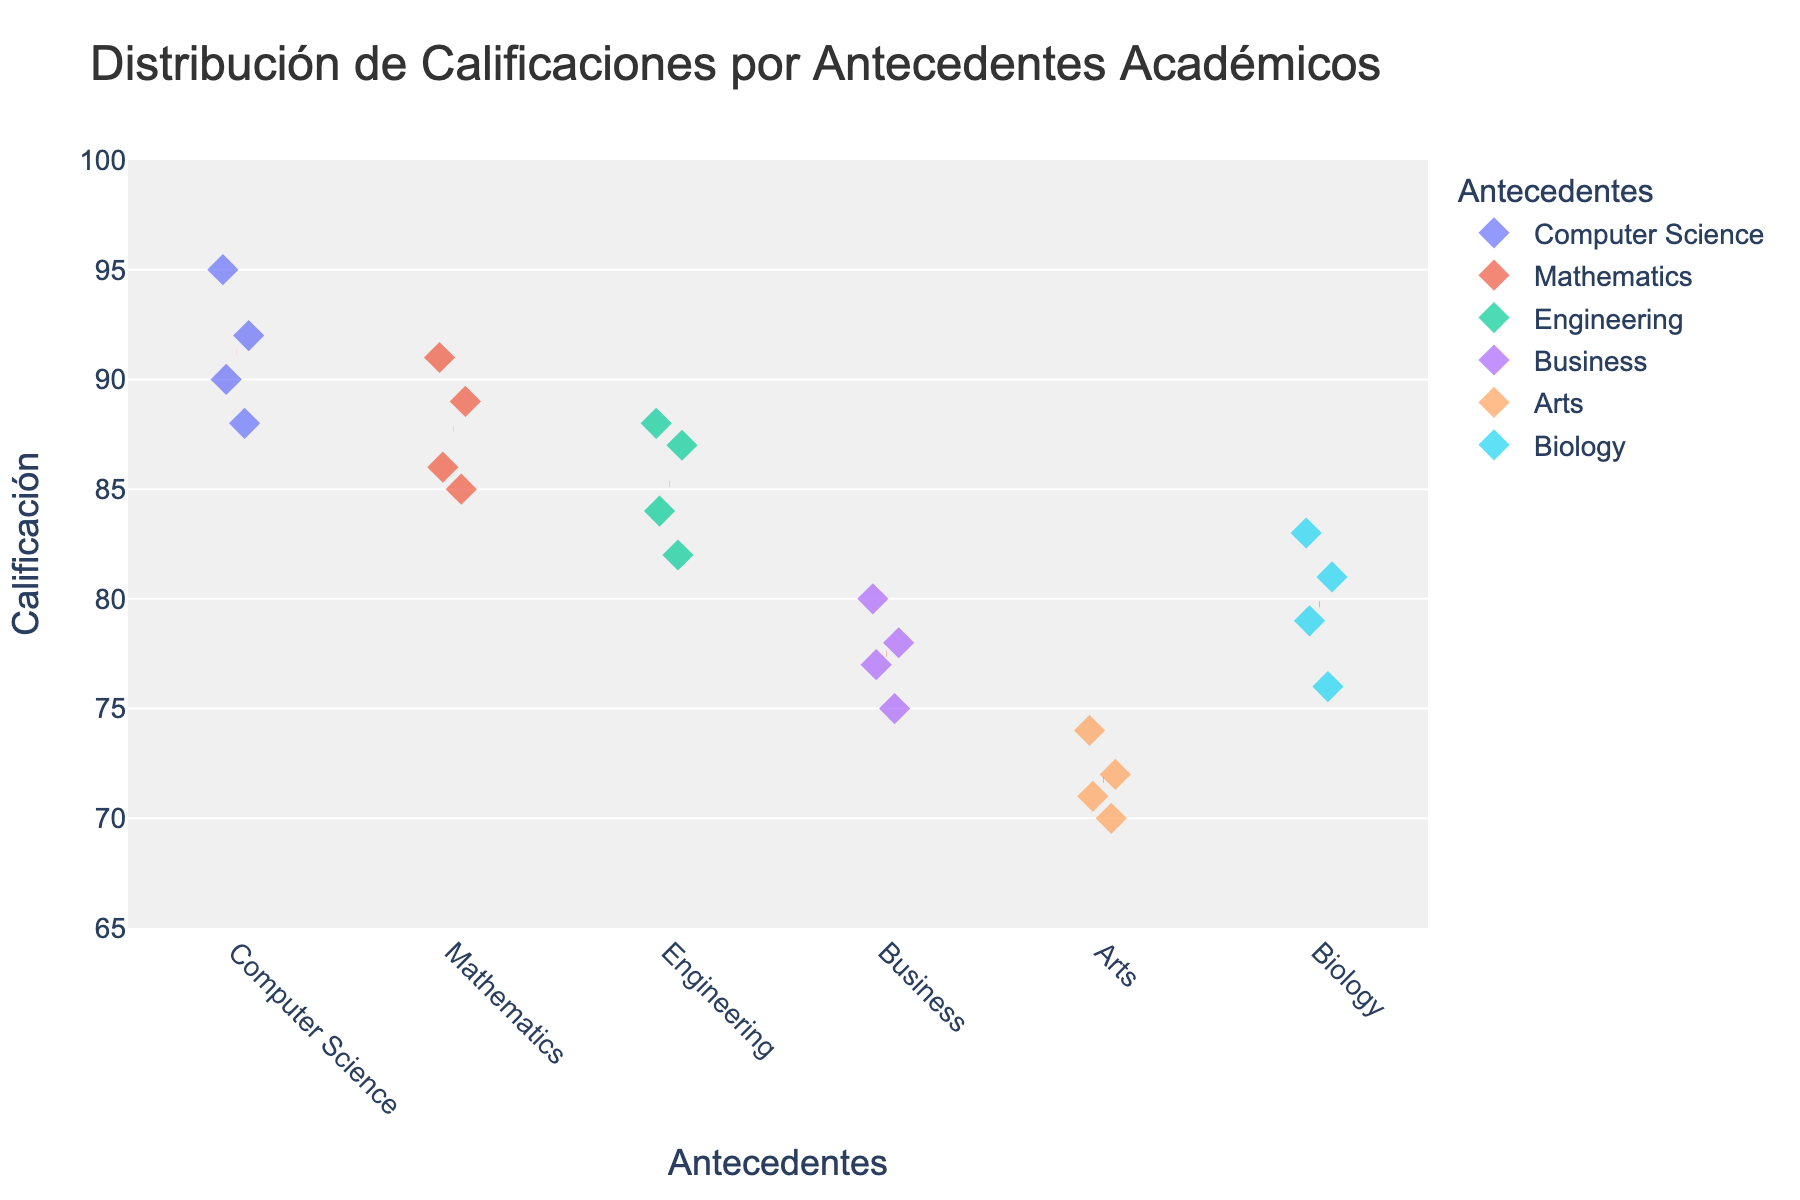What is the title of the plot? The title is written at the top of the plot where it summarizes the entire figure.
Answer: Distribución de Calificaciones por Antecedentes Académicos What is the range of the y-axis? The y-axis range is displayed on the left side of the plot, showing the scale of values. It goes from 65 to 100 in steps of 5.
Answer: 65 to 100 How many different academic backgrounds are displayed on the x-axis? The x-axis has labels representing the different academic backgrounds, which can be counted to determine the number of groups.
Answer: 6 Which academic background has the highest mean grade? The red dashed lines indicate the mean grade for each academic background. By comparing the positions of these lines, Computer Science has the highest mean grade.
Answer: Computer Science Which group has the most clustered grades? Observing how closely the grades are grouped together around the mean or in the spread of data points, Computer Science grades appear most clustered.
Answer: Computer Science What's the average grade for students with a Mathematics background? Locate the red dashed line over the Mathematics group on the plot; it marks the mean grade for this group. The value closely aligns around a grade of approximately 87.75.
Answer: 87.75 Are there any grades below 75? Look along the y-axis to see if any data points fall below the 75-mark. The Arts and Business backgrounds contain grades below 75.
Answer: Yes What's the grade range for students with Engineering backgrounds? The range is the difference between the highest and lowest grade points in the Engineering group, from 82 to 88, giving a range of 6.
Answer: 82 to 88 Which academic backgrounds have at least one student scoring above 90? By observing the y-axis and locating the points above 90, Computer Science and Mathematics groups have at least one student scoring above 90.
Answer: Computer Science, Mathematics 